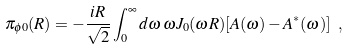Convert formula to latex. <formula><loc_0><loc_0><loc_500><loc_500>\pi _ { \phi 0 } ( R ) = - \frac { i R } { \sqrt { 2 } } \int _ { 0 } ^ { \infty } d \omega \, \omega J _ { 0 } ( \omega R ) [ A ( \omega ) - A ^ { * } ( \omega ) ] \ ,</formula> 